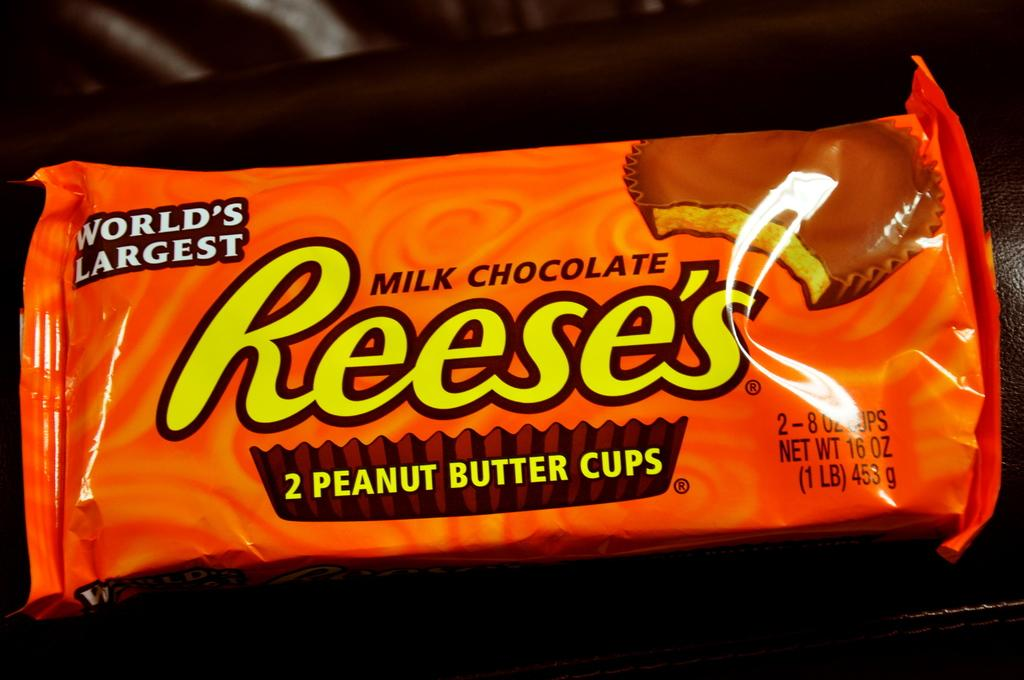<image>
Create a compact narrative representing the image presented. An orange package of two Reese's Peanut Butter cups. 